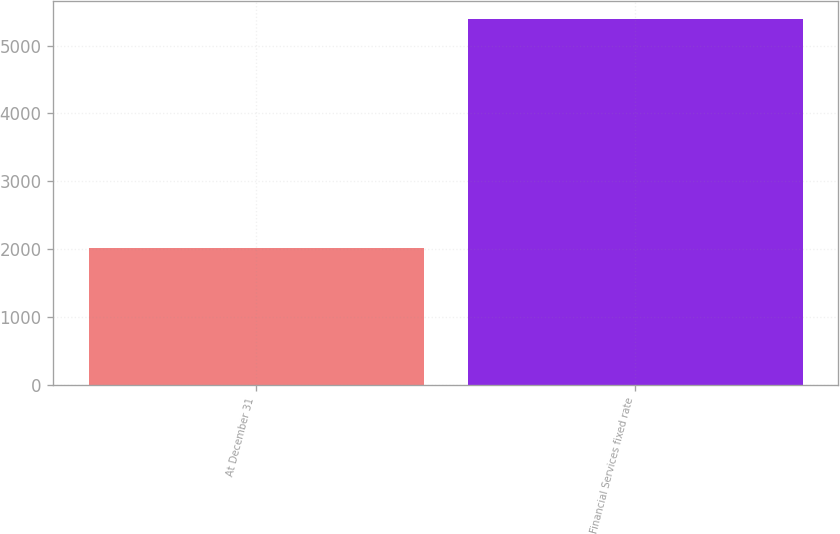Convert chart. <chart><loc_0><loc_0><loc_500><loc_500><bar_chart><fcel>At December 31<fcel>Financial Services fixed rate<nl><fcel>2017<fcel>5387<nl></chart> 